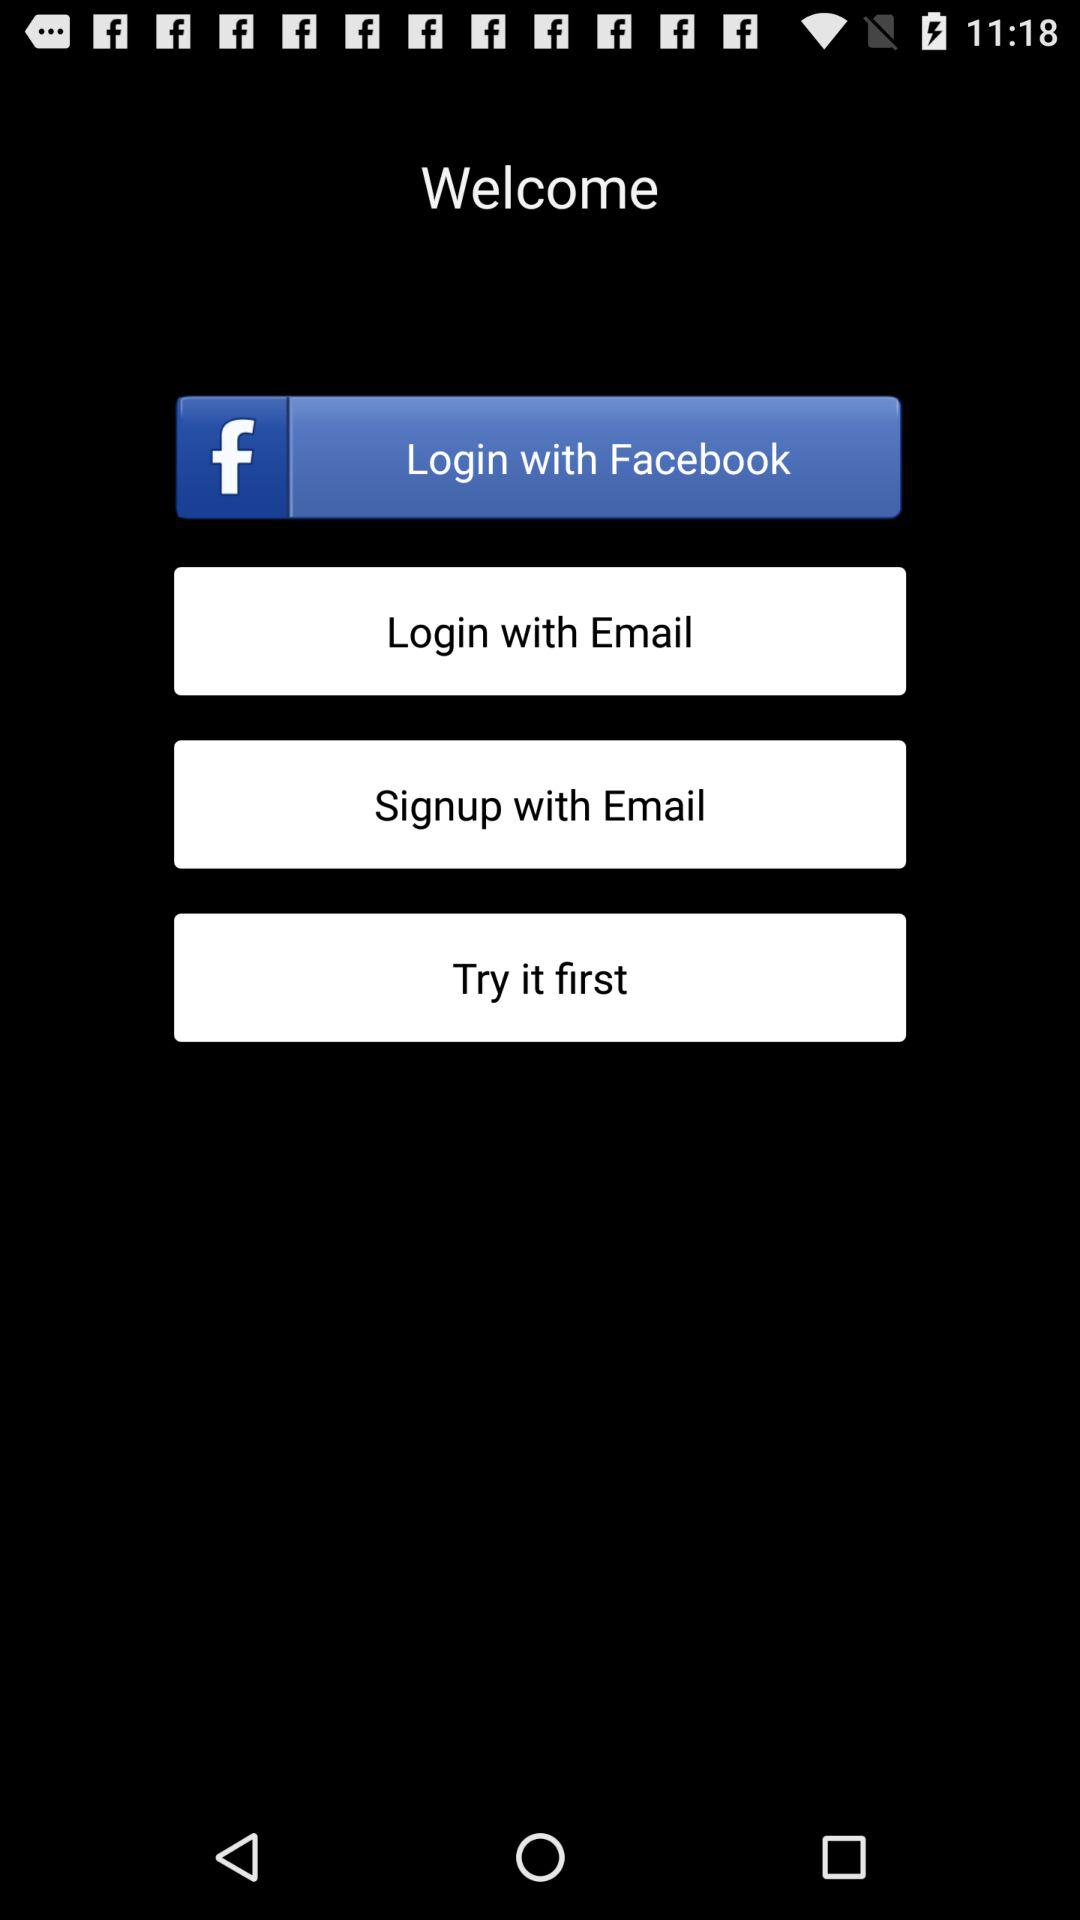What's the account name by which user can Signup? The account name is "Email". 